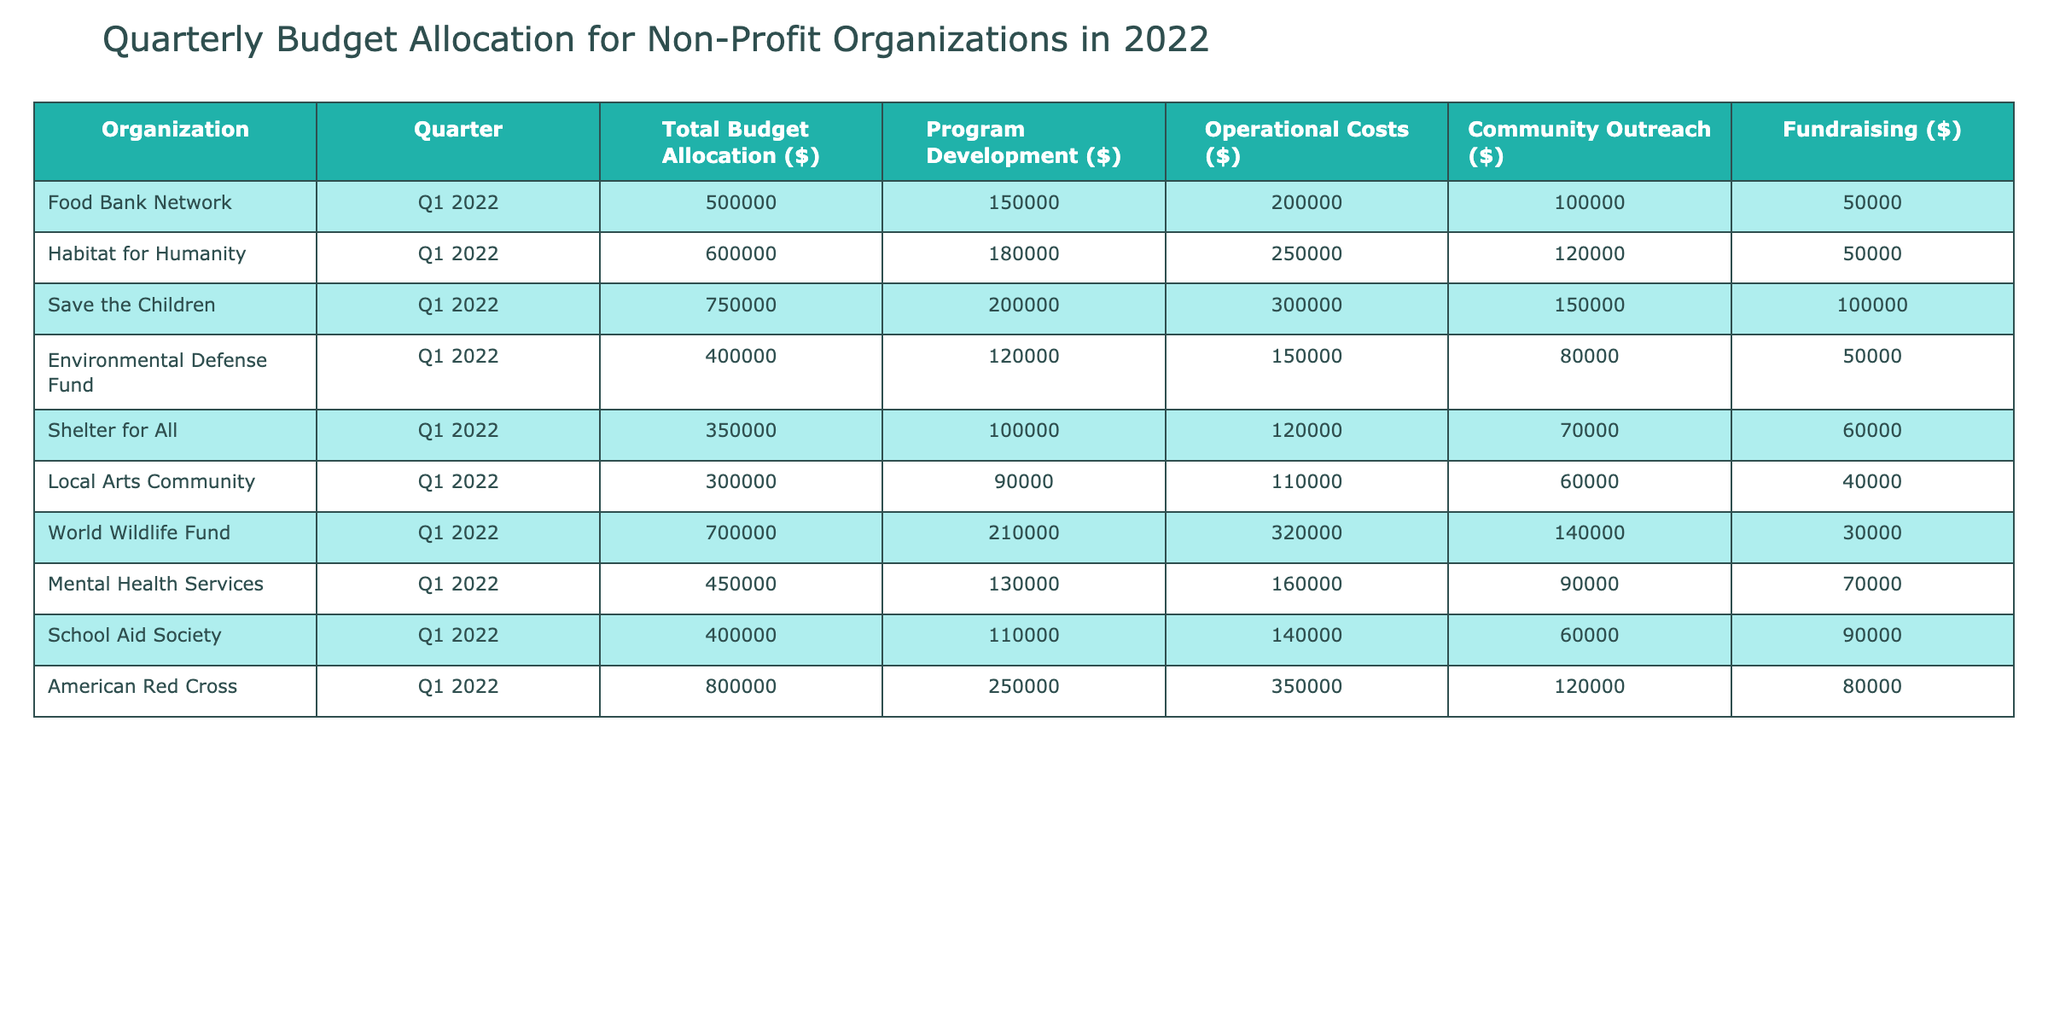What is the total budget allocation for the American Red Cross in Q1 2022? The table lists the total budget allocation for the American Red Cross as $800,000. This value is found directly under the 'Total Budget Allocation ($)' column next to 'American Red Cross'.
Answer: 800000 Which organization allocated the highest amount for Community Outreach in Q1 2022? By examining the values in the 'Community Outreach ($)' column, Save the Children allocated $150,000, which is higher than any other organization listed. Thus, Save the Children has the highest allocation for Community Outreach.
Answer: Save the Children What is the total amount allocated for Operational Costs among all organizations in Q1 2022? To find the total allocated for Operational Costs, we sum all the values under that column: 200,000 + 250,000 + 300,000 + 150,000 + 120,000 + 110,000 + 320,000 + 160,000 + 140,000 + 350,000 = 1,940,000. This involves adding each individual organization's operational costs together.
Answer: 1940000 Did any organization allocate more than half a million dollars for Program Development in Q1 2022? Checking the 'Program Development ($)' column, American Red Cross with $250,000 is the highest. All organizations have allocations below $500,000 for this category, confirming that none exceeded that threshold.
Answer: No What is the average total budget allocation of the organizations listed? First, we find the sum of all total budget allocations: 500,000 + 600,000 + 750,000 + 400,000 + 350,000 + 300,000 + 700,000 + 450,000 + 400,000 + 800,000 = 4,750,000. Next, we divide this by the number of organizations (10), leading to an average of 4,750,000 / 10 = 475,000.
Answer: 475000 What percentage of the total budget allocation does the Environmental Defense Fund dedicate to Operational Costs? The Environmental Defense Fund's total budget is $400,000, and the Operational Costs are $150,000. To find the percentage: (150,000 / 400,000) * 100 = 37.5%. This involves determining the ratio of Operational Costs to the total budget and converting it into a percentage.
Answer: 37.5% List the organizations that have equal or greater fundraising allocations than Mental Health Services. Mental Health Services has a fundraising allocation of $70,000. By comparing this figure to others, we find that the Food Bank Network ($50,000), Habitat for Humanity ($50,000), and Local Arts Community ($40,000) all allocate less. Only Shelter for All ($60,000) and School Aid Society ($90,000) exceed it. Therefore, the organizations include: School Aid Society.
Answer: School Aid Society Which organization has the lowest total budget allocation, and what is that amount? The allocation for Shelter for All is the lowest among the listed, with a total budget of $350,000. A quick check through the 'Total Budget Allocation ($)' column confirms that all other amounts are higher.
Answer: 350000 Is the total budget allocation for the World Wildlife Fund greater than the combined allocation of the Food Bank Network and Local Arts Community? The total for World Wildlife Fund is $700,000. Adding the allocations for the other two gives: Food Bank Network $500,000 + Local Arts Community $300,000 = $800,000. Since $700,000 < $800,000, the World Wildlife Fund's allocation is indeed less.
Answer: No 